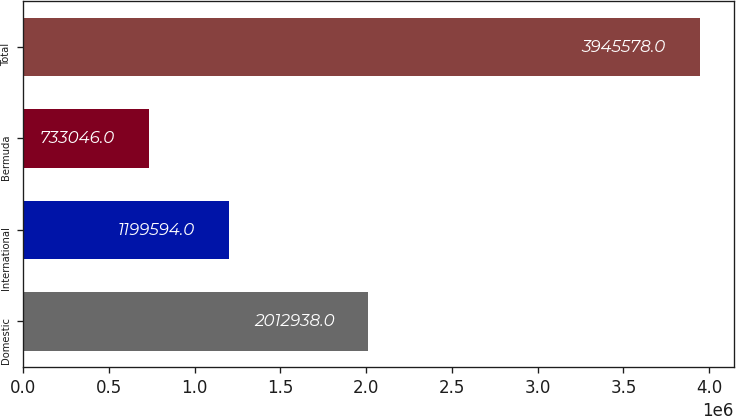Convert chart. <chart><loc_0><loc_0><loc_500><loc_500><bar_chart><fcel>Domestic<fcel>International<fcel>Bermuda<fcel>Total<nl><fcel>2.01294e+06<fcel>1.19959e+06<fcel>733046<fcel>3.94558e+06<nl></chart> 